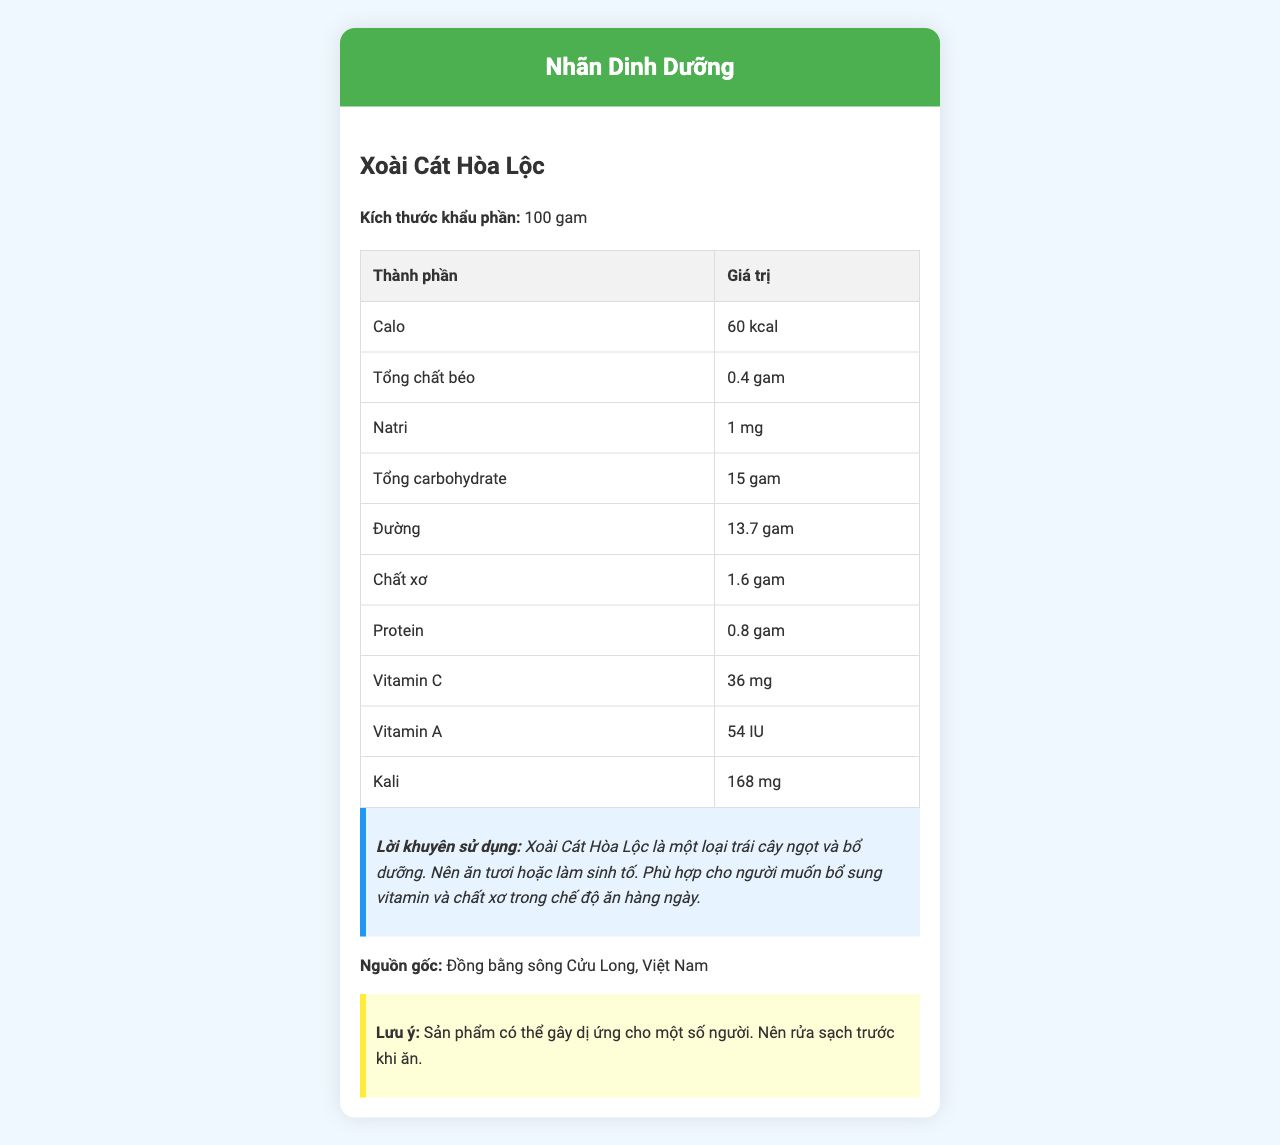what is the calo amount in 100 grams of the product? According to the nutrition facts, 100 grams of Xoài Cát Hòa Lộc contains 60 kcal.
Answer: 60 kcal how much fiber is in a serving? The listed amount of fiber in the serving size (100 grams) is 1.6 grams.
Answer: 1.6 grams What type of vitamin is most abundant in Xoài Cát Hòa Lộc? A. Vitamin C B. Vitamin A C. Vitamin D The document states that there are 36 mg of Vitamin C compared to 54 IU of Vitamin A, and it's the only vitamin explicitly mentioned in high quantity.
Answer: A. Vitamin C how much total carbohydrate is present? The document specifies that there are 15 grams of total carbohydrates in 100 grams of Xoài Cát Hòa Lộc.
Answer: 15 grams What is the sodium content in the product? It mentions that the product has 1 mg of sodium per 100 grams.
Answer: 1 mg how much protein does 100 grams of Xoài Cát Hòa Lộc have? The nutrition label indicates 0.8 grams of protein per 100 grams.
Answer: 0.8 grams which nutrient is listed with the highest value in milligrams? A. Natri B. Vitamin C C. Kali The product has 168 mg of potassium (Kali) which is the highest value among other milligram-based nutrients listed.
Answer: C. Kali should people wash the fruit before eating it? The document explicitly advises to wash the fruit clean before consumption.
Answer: Yes Can you determine how many calories come from fat? The document does not provide details on the number of calories specifically coming from fat.
Answer: Not enough information what is the origin of Xoài Cát Hòa Lộc? The document specifies that the origin of the product is Đồng bằng sông Cửu Long, Việt Nam.
Answer: Đồng bằng sông Cửu Long, Việt Nam (Mekong Delta, Vietnam) is Xoài Cát Hòa Lộc free from potential allergens? The document mentions that the product may cause allergies for some people.
Answer: No describe the general nutritional information and guidelines provided in the document The label organizes the nutrient values in a tabular form, outlines usage recommendations focusing on health benefits (vitamin and fiber content), mentions the geographical origin of the product (Mekong Delta), and highlights safety instructions (allergy and washing).
Answer: The document provides nutritional facts for Xoài Cát Hòa Lộc in a serving size of 100 grams. It includes detailed information about calories, fats, sodium, carbohydrates, sugar, fiber, protein, vitamin C, vitamin A, and potassium. It also offers usage advice, indicating that the fruit can be eaten fresh or used in smoothies and is beneficial for vitamin and fiber intake. There's also a note on the fruit's origin and a warning about potential allergies and the importance of washing the fruit before eating it. is there any mention of fat types such as saturated or unsaturated fats? The document only provides information about the total amount of fat and does not specify the types of fat.
Answer: No how should the fruit be consumed for optimal benefits? The recommendation provided indicates that the fruit is sweet and nutritious and can be consumed fresh or used in smoothies for optimal benefits.
Answer: The fruit should be eaten fresh or made into smoothies. what is the amount of Vitamin A given in? Vitamin A is listed with a value in IU, specifically 54 IU.
Answer: IU (International Units) 